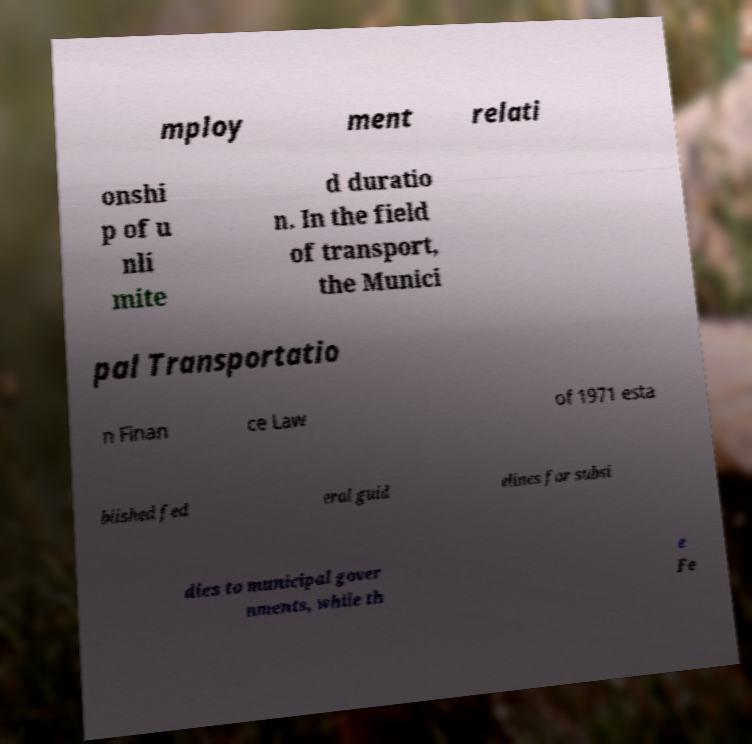I need the written content from this picture converted into text. Can you do that? mploy ment relati onshi p of u nli mite d duratio n. In the field of transport, the Munici pal Transportatio n Finan ce Law of 1971 esta blished fed eral guid elines for subsi dies to municipal gover nments, while th e Fe 